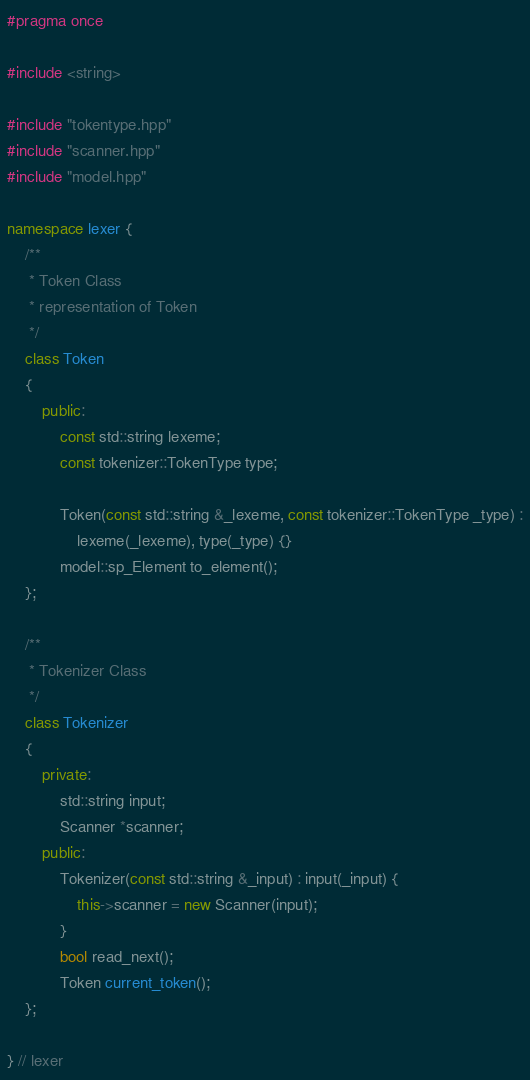<code> <loc_0><loc_0><loc_500><loc_500><_C++_>#pragma once

#include <string>

#include "tokentype.hpp"
#include "scanner.hpp"
#include "model.hpp"

namespace lexer {
	/**
	 * Token Class
	 * representation of Token
	 */
	class Token
	{
		public:
			const std::string lexeme;
			const tokenizer::TokenType type;

			Token(const std::string &_lexeme, const tokenizer::TokenType _type) :
				lexeme(_lexeme), type(_type) {}
			model::sp_Element to_element();
	};

	/**
	 * Tokenizer Class
	 */
	class Tokenizer
	{
		private:
			std::string input;
			Scanner *scanner;
		public:
			Tokenizer(const std::string &_input) : input(_input) {
				this->scanner = new Scanner(input);
			}
			bool read_next();
			Token current_token();
	};

} // lexer
</code> 